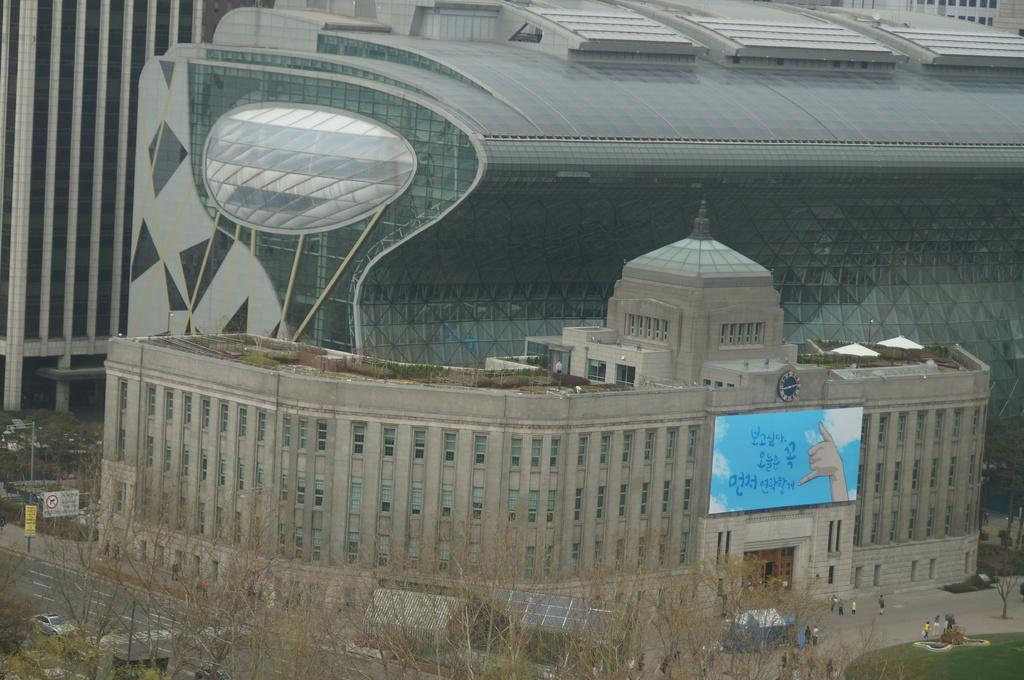What type of structures can be seen in the background of the image? There are buildings in the background of the image. What natural elements are present in front of the buildings? There are trees in front of the buildings in the image. What type of weather condition is responsible for the sleet in the image? There is no sleet present in the image; it only features buildings and trees. 